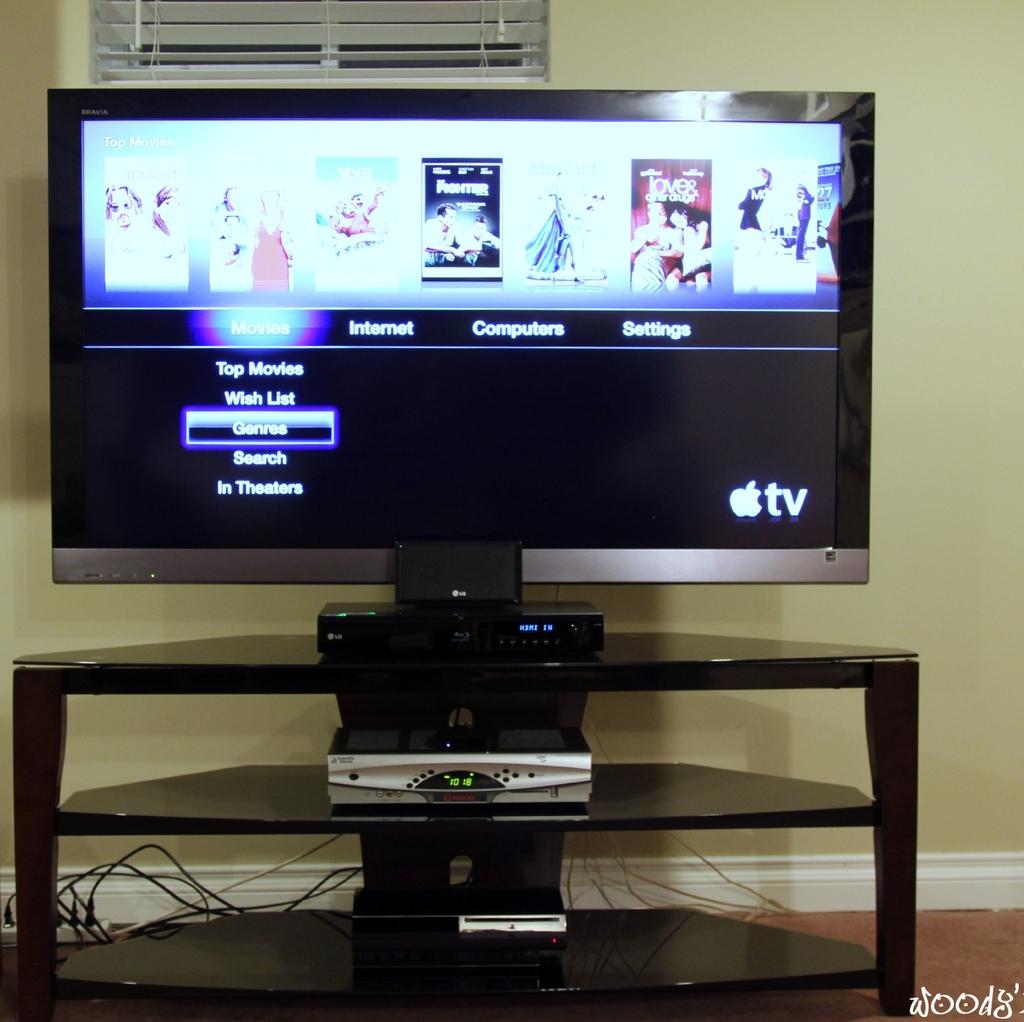Is this an apple tv?
Keep it short and to the point. Yes. 